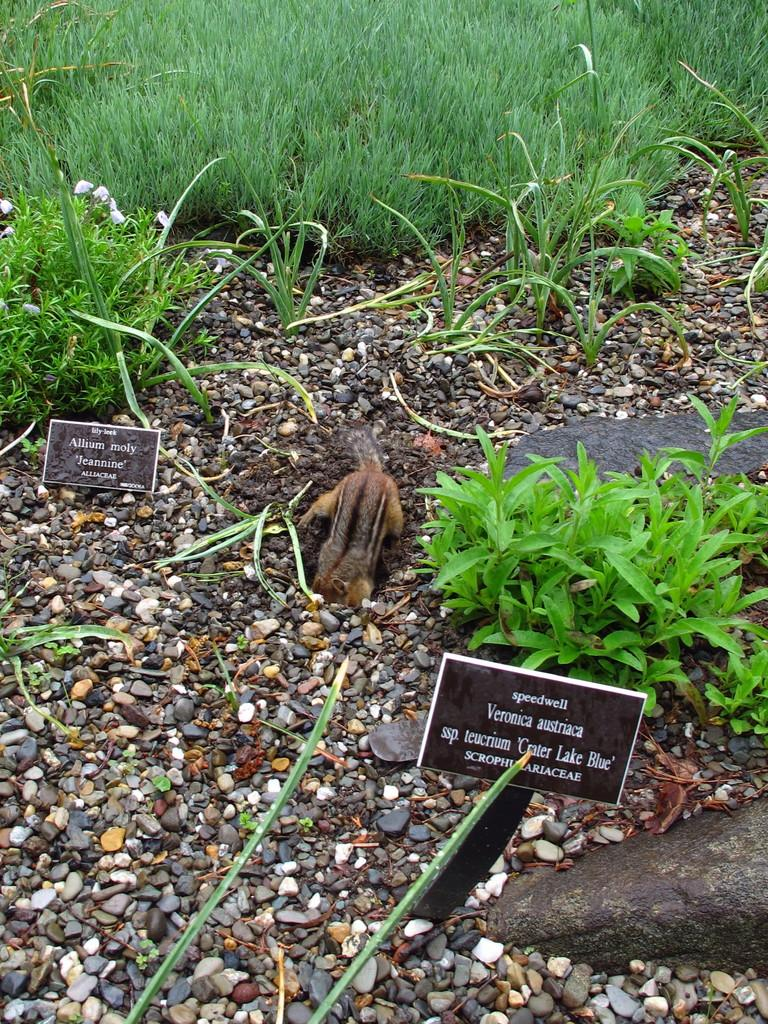What is the main subject in the foreground of the image? There is a squirrel in the foreground of the image. What other objects or elements can be seen in the foreground of the image? There are stones, plants, boards, and grass in the foreground of the image. Can you help the squirrel reach the apple in the image? There is no apple present in the image, so it is not possible to help the squirrel reach it. 